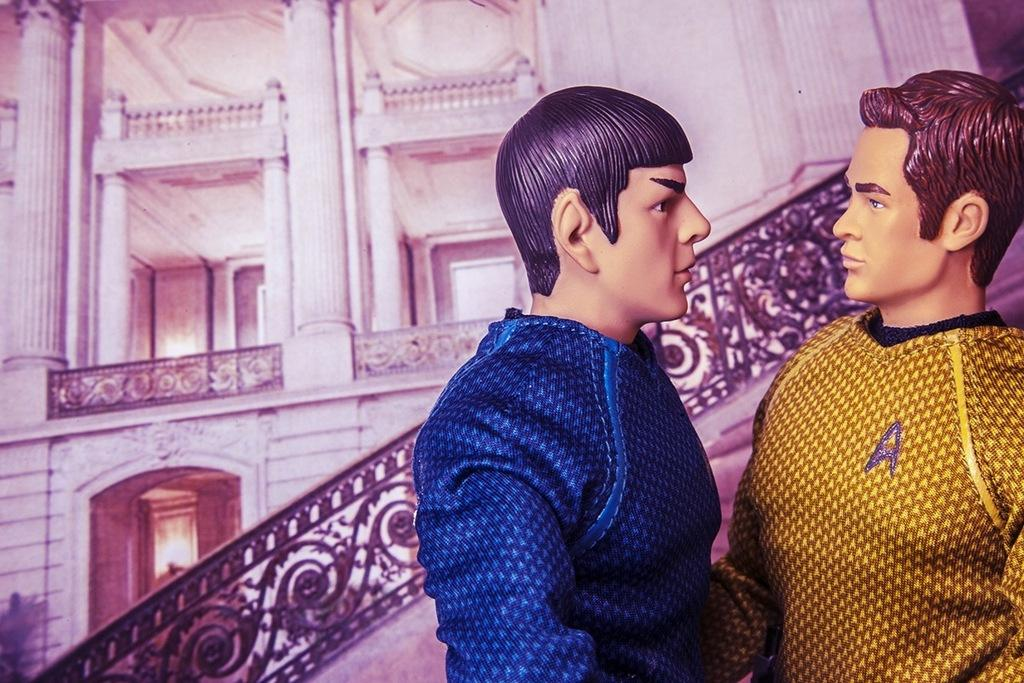What type of structure can be seen in the background of the image? There is a building in the background of the image. What is the color of the railing in the image? The railing in the image is black. How many people are present in the image? There are two men in the image. What is the nature of the men in the image? The men appear to be toys. What type of camp can be seen in the image? There is no camp present in the image. How many spiders are crawling on the men in the image? There are no spiders present in the image. 